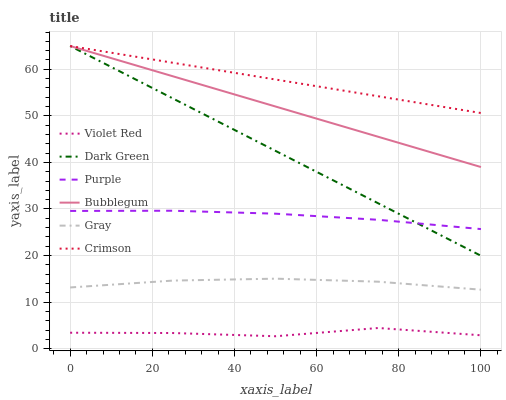Does Purple have the minimum area under the curve?
Answer yes or no. No. Does Purple have the maximum area under the curve?
Answer yes or no. No. Is Purple the smoothest?
Answer yes or no. No. Is Purple the roughest?
Answer yes or no. No. Does Purple have the lowest value?
Answer yes or no. No. Does Purple have the highest value?
Answer yes or no. No. Is Gray less than Crimson?
Answer yes or no. Yes. Is Bubblegum greater than Gray?
Answer yes or no. Yes. Does Gray intersect Crimson?
Answer yes or no. No. 